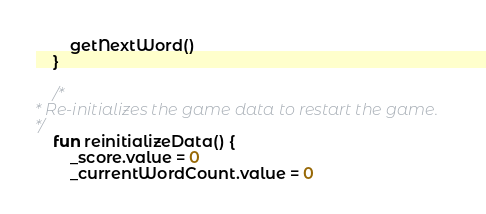Convert code to text. <code><loc_0><loc_0><loc_500><loc_500><_Kotlin_>        getNextWord()
    }

    /*
* Re-initializes the game data to restart the game.
*/
    fun reinitializeData() {
        _score.value = 0
        _currentWordCount.value = 0</code> 